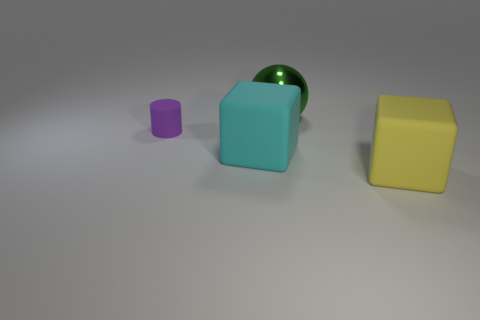Add 2 small red rubber objects. How many objects exist? 6 Subtract all cylinders. How many objects are left? 3 Subtract all big red shiny cylinders. Subtract all large cyan cubes. How many objects are left? 3 Add 2 rubber cylinders. How many rubber cylinders are left? 3 Add 3 tiny purple rubber cylinders. How many tiny purple rubber cylinders exist? 4 Subtract 0 purple blocks. How many objects are left? 4 